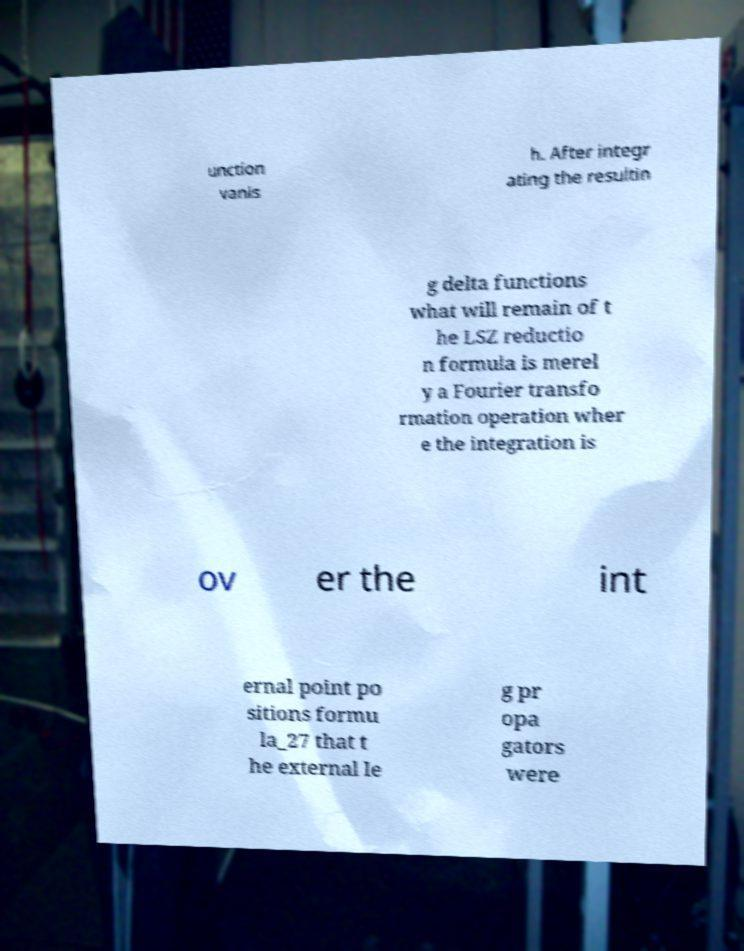Could you assist in decoding the text presented in this image and type it out clearly? unction vanis h. After integr ating the resultin g delta functions what will remain of t he LSZ reductio n formula is merel y a Fourier transfo rmation operation wher e the integration is ov er the int ernal point po sitions formu la_27 that t he external le g pr opa gators were 